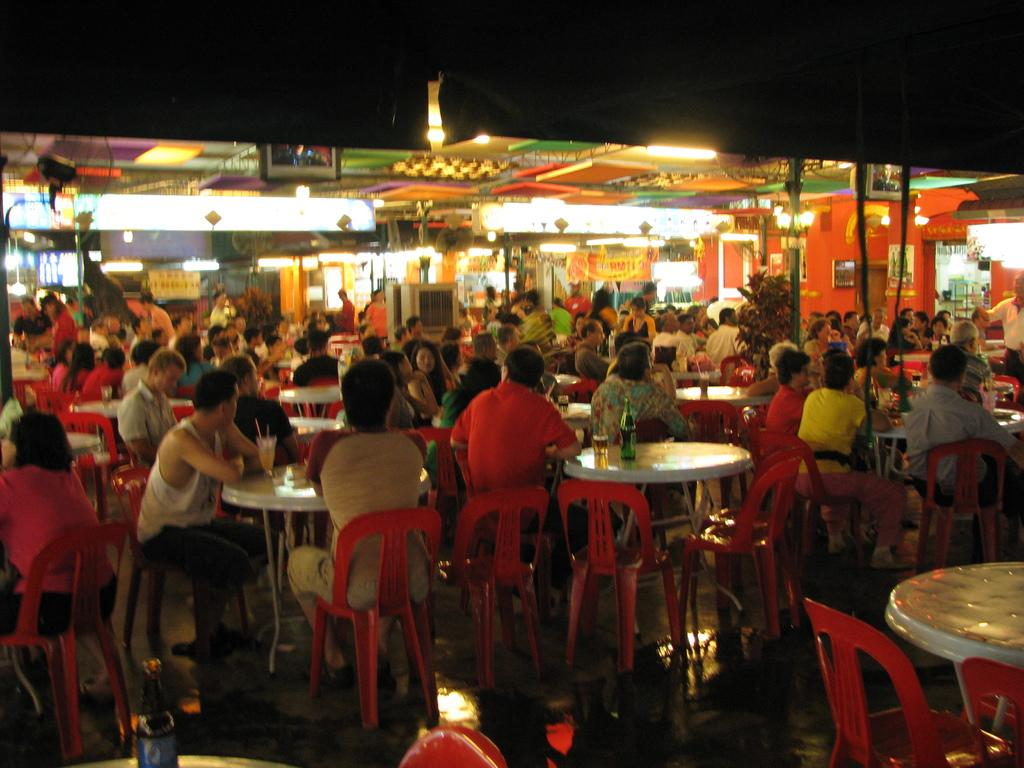How many people are in the image? There is a group of persons in the image, but the exact number is not specified. What are the chairs that the persons are sitting on like? The persons are sitting in red chairs. What is the color of the table in front of the group of persons? There is a white table in front of the group of persons. Is the table made of quicksand in the image? No, the table is not made of quicksand; it is white, as mentioned in the facts. 